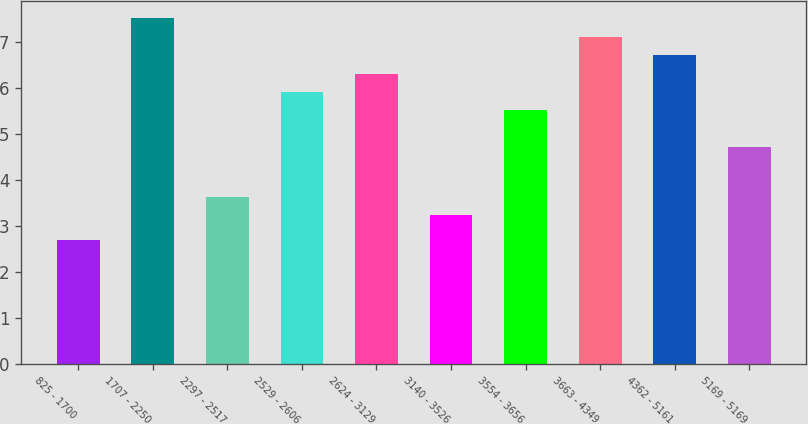<chart> <loc_0><loc_0><loc_500><loc_500><bar_chart><fcel>825 - 1700<fcel>1707 - 2250<fcel>2297 - 2517<fcel>2529 - 2606<fcel>2624 - 3129<fcel>3140 - 3526<fcel>3554 - 3656<fcel>3663 - 4349<fcel>4362 - 5161<fcel>5169 - 5169<nl><fcel>2.69<fcel>7.52<fcel>3.64<fcel>5.92<fcel>6.32<fcel>3.24<fcel>5.52<fcel>7.12<fcel>6.72<fcel>4.72<nl></chart> 